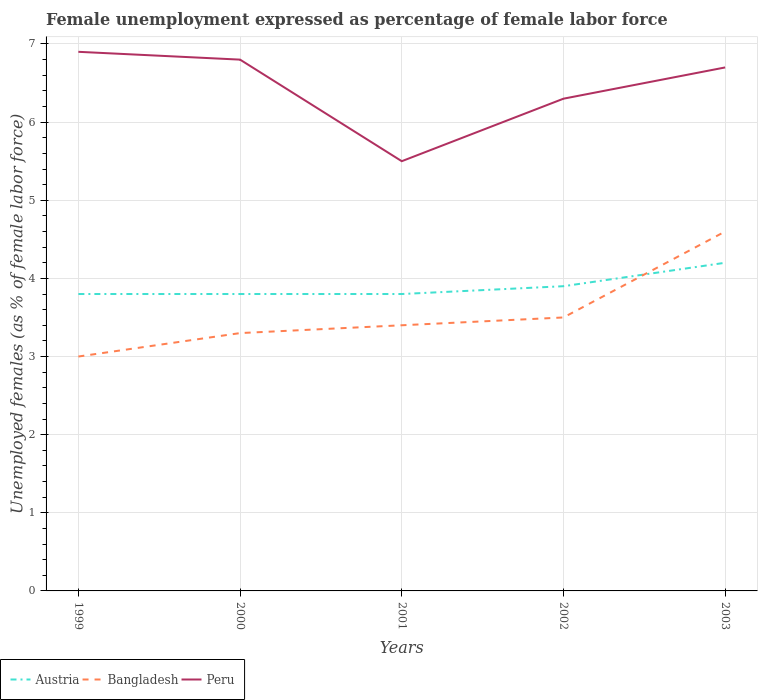Does the line corresponding to Bangladesh intersect with the line corresponding to Austria?
Make the answer very short. Yes. Across all years, what is the maximum unemployment in females in in Bangladesh?
Give a very brief answer. 3. In which year was the unemployment in females in in Austria maximum?
Make the answer very short. 1999. What is the total unemployment in females in in Austria in the graph?
Give a very brief answer. 0. What is the difference between the highest and the second highest unemployment in females in in Austria?
Keep it short and to the point. 0.4. What is the difference between the highest and the lowest unemployment in females in in Austria?
Ensure brevity in your answer.  2. How many lines are there?
Your answer should be very brief. 3. How many years are there in the graph?
Offer a very short reply. 5. Are the values on the major ticks of Y-axis written in scientific E-notation?
Your answer should be very brief. No. Does the graph contain grids?
Provide a succinct answer. Yes. How are the legend labels stacked?
Make the answer very short. Horizontal. What is the title of the graph?
Give a very brief answer. Female unemployment expressed as percentage of female labor force. Does "New Caledonia" appear as one of the legend labels in the graph?
Provide a succinct answer. No. What is the label or title of the X-axis?
Offer a terse response. Years. What is the label or title of the Y-axis?
Provide a succinct answer. Unemployed females (as % of female labor force). What is the Unemployed females (as % of female labor force) in Austria in 1999?
Your answer should be compact. 3.8. What is the Unemployed females (as % of female labor force) of Peru in 1999?
Your response must be concise. 6.9. What is the Unemployed females (as % of female labor force) of Austria in 2000?
Offer a terse response. 3.8. What is the Unemployed females (as % of female labor force) in Bangladesh in 2000?
Your answer should be compact. 3.3. What is the Unemployed females (as % of female labor force) in Peru in 2000?
Offer a terse response. 6.8. What is the Unemployed females (as % of female labor force) in Austria in 2001?
Give a very brief answer. 3.8. What is the Unemployed females (as % of female labor force) in Bangladesh in 2001?
Give a very brief answer. 3.4. What is the Unemployed females (as % of female labor force) of Austria in 2002?
Keep it short and to the point. 3.9. What is the Unemployed females (as % of female labor force) of Peru in 2002?
Ensure brevity in your answer.  6.3. What is the Unemployed females (as % of female labor force) in Austria in 2003?
Make the answer very short. 4.2. What is the Unemployed females (as % of female labor force) in Bangladesh in 2003?
Your answer should be compact. 4.6. What is the Unemployed females (as % of female labor force) in Peru in 2003?
Your answer should be very brief. 6.7. Across all years, what is the maximum Unemployed females (as % of female labor force) in Austria?
Keep it short and to the point. 4.2. Across all years, what is the maximum Unemployed females (as % of female labor force) in Bangladesh?
Your answer should be very brief. 4.6. Across all years, what is the maximum Unemployed females (as % of female labor force) of Peru?
Your answer should be compact. 6.9. Across all years, what is the minimum Unemployed females (as % of female labor force) of Austria?
Your response must be concise. 3.8. Across all years, what is the minimum Unemployed females (as % of female labor force) in Bangladesh?
Your response must be concise. 3. What is the total Unemployed females (as % of female labor force) of Peru in the graph?
Your response must be concise. 32.2. What is the difference between the Unemployed females (as % of female labor force) in Peru in 1999 and that in 2000?
Keep it short and to the point. 0.1. What is the difference between the Unemployed females (as % of female labor force) of Austria in 1999 and that in 2001?
Make the answer very short. 0. What is the difference between the Unemployed females (as % of female labor force) of Bangladesh in 1999 and that in 2001?
Offer a very short reply. -0.4. What is the difference between the Unemployed females (as % of female labor force) of Peru in 1999 and that in 2001?
Offer a terse response. 1.4. What is the difference between the Unemployed females (as % of female labor force) of Austria in 1999 and that in 2002?
Your answer should be compact. -0.1. What is the difference between the Unemployed females (as % of female labor force) in Peru in 1999 and that in 2002?
Your answer should be compact. 0.6. What is the difference between the Unemployed females (as % of female labor force) of Austria in 2000 and that in 2002?
Your response must be concise. -0.1. What is the difference between the Unemployed females (as % of female labor force) in Bangladesh in 2000 and that in 2002?
Offer a very short reply. -0.2. What is the difference between the Unemployed females (as % of female labor force) of Peru in 2000 and that in 2002?
Offer a terse response. 0.5. What is the difference between the Unemployed females (as % of female labor force) of Austria in 2000 and that in 2003?
Offer a very short reply. -0.4. What is the difference between the Unemployed females (as % of female labor force) of Bangladesh in 2001 and that in 2002?
Ensure brevity in your answer.  -0.1. What is the difference between the Unemployed females (as % of female labor force) of Peru in 2001 and that in 2002?
Provide a short and direct response. -0.8. What is the difference between the Unemployed females (as % of female labor force) of Austria in 2001 and that in 2003?
Provide a succinct answer. -0.4. What is the difference between the Unemployed females (as % of female labor force) in Bangladesh in 2001 and that in 2003?
Give a very brief answer. -1.2. What is the difference between the Unemployed females (as % of female labor force) in Peru in 2002 and that in 2003?
Offer a very short reply. -0.4. What is the difference between the Unemployed females (as % of female labor force) of Austria in 1999 and the Unemployed females (as % of female labor force) of Peru in 2000?
Your answer should be compact. -3. What is the difference between the Unemployed females (as % of female labor force) in Bangladesh in 1999 and the Unemployed females (as % of female labor force) in Peru in 2000?
Ensure brevity in your answer.  -3.8. What is the difference between the Unemployed females (as % of female labor force) in Bangladesh in 1999 and the Unemployed females (as % of female labor force) in Peru in 2001?
Your answer should be compact. -2.5. What is the difference between the Unemployed females (as % of female labor force) in Austria in 1999 and the Unemployed females (as % of female labor force) in Peru in 2002?
Provide a short and direct response. -2.5. What is the difference between the Unemployed females (as % of female labor force) of Austria in 1999 and the Unemployed females (as % of female labor force) of Peru in 2003?
Provide a short and direct response. -2.9. What is the difference between the Unemployed females (as % of female labor force) in Bangladesh in 1999 and the Unemployed females (as % of female labor force) in Peru in 2003?
Your answer should be compact. -3.7. What is the difference between the Unemployed females (as % of female labor force) in Austria in 2000 and the Unemployed females (as % of female labor force) in Bangladesh in 2001?
Provide a succinct answer. 0.4. What is the difference between the Unemployed females (as % of female labor force) of Austria in 2000 and the Unemployed females (as % of female labor force) of Peru in 2001?
Your answer should be compact. -1.7. What is the difference between the Unemployed females (as % of female labor force) in Bangladesh in 2000 and the Unemployed females (as % of female labor force) in Peru in 2001?
Give a very brief answer. -2.2. What is the difference between the Unemployed females (as % of female labor force) of Austria in 2000 and the Unemployed females (as % of female labor force) of Bangladesh in 2002?
Give a very brief answer. 0.3. What is the difference between the Unemployed females (as % of female labor force) in Austria in 2000 and the Unemployed females (as % of female labor force) in Peru in 2002?
Provide a short and direct response. -2.5. What is the difference between the Unemployed females (as % of female labor force) in Bangladesh in 2000 and the Unemployed females (as % of female labor force) in Peru in 2002?
Keep it short and to the point. -3. What is the difference between the Unemployed females (as % of female labor force) of Austria in 2001 and the Unemployed females (as % of female labor force) of Peru in 2002?
Keep it short and to the point. -2.5. What is the difference between the Unemployed females (as % of female labor force) in Bangladesh in 2001 and the Unemployed females (as % of female labor force) in Peru in 2002?
Your answer should be compact. -2.9. What is the difference between the Unemployed females (as % of female labor force) in Austria in 2001 and the Unemployed females (as % of female labor force) in Bangladesh in 2003?
Your answer should be compact. -0.8. What is the difference between the Unemployed females (as % of female labor force) of Austria in 2001 and the Unemployed females (as % of female labor force) of Peru in 2003?
Make the answer very short. -2.9. What is the average Unemployed females (as % of female labor force) in Bangladesh per year?
Provide a short and direct response. 3.56. What is the average Unemployed females (as % of female labor force) of Peru per year?
Offer a terse response. 6.44. In the year 2000, what is the difference between the Unemployed females (as % of female labor force) in Austria and Unemployed females (as % of female labor force) in Peru?
Ensure brevity in your answer.  -3. In the year 2000, what is the difference between the Unemployed females (as % of female labor force) in Bangladesh and Unemployed females (as % of female labor force) in Peru?
Your answer should be compact. -3.5. In the year 2001, what is the difference between the Unemployed females (as % of female labor force) of Austria and Unemployed females (as % of female labor force) of Peru?
Ensure brevity in your answer.  -1.7. In the year 2002, what is the difference between the Unemployed females (as % of female labor force) in Austria and Unemployed females (as % of female labor force) in Bangladesh?
Your answer should be very brief. 0.4. In the year 2003, what is the difference between the Unemployed females (as % of female labor force) in Austria and Unemployed females (as % of female labor force) in Bangladesh?
Make the answer very short. -0.4. What is the ratio of the Unemployed females (as % of female labor force) in Austria in 1999 to that in 2000?
Your answer should be very brief. 1. What is the ratio of the Unemployed females (as % of female labor force) of Bangladesh in 1999 to that in 2000?
Make the answer very short. 0.91. What is the ratio of the Unemployed females (as % of female labor force) in Peru in 1999 to that in 2000?
Provide a succinct answer. 1.01. What is the ratio of the Unemployed females (as % of female labor force) of Austria in 1999 to that in 2001?
Your response must be concise. 1. What is the ratio of the Unemployed females (as % of female labor force) of Bangladesh in 1999 to that in 2001?
Your response must be concise. 0.88. What is the ratio of the Unemployed females (as % of female labor force) in Peru in 1999 to that in 2001?
Make the answer very short. 1.25. What is the ratio of the Unemployed females (as % of female labor force) in Austria in 1999 to that in 2002?
Provide a short and direct response. 0.97. What is the ratio of the Unemployed females (as % of female labor force) of Bangladesh in 1999 to that in 2002?
Give a very brief answer. 0.86. What is the ratio of the Unemployed females (as % of female labor force) of Peru in 1999 to that in 2002?
Your response must be concise. 1.1. What is the ratio of the Unemployed females (as % of female labor force) of Austria in 1999 to that in 2003?
Provide a short and direct response. 0.9. What is the ratio of the Unemployed females (as % of female labor force) of Bangladesh in 1999 to that in 2003?
Make the answer very short. 0.65. What is the ratio of the Unemployed females (as % of female labor force) of Peru in 1999 to that in 2003?
Ensure brevity in your answer.  1.03. What is the ratio of the Unemployed females (as % of female labor force) of Austria in 2000 to that in 2001?
Ensure brevity in your answer.  1. What is the ratio of the Unemployed females (as % of female labor force) in Bangladesh in 2000 to that in 2001?
Your answer should be very brief. 0.97. What is the ratio of the Unemployed females (as % of female labor force) in Peru in 2000 to that in 2001?
Your answer should be compact. 1.24. What is the ratio of the Unemployed females (as % of female labor force) of Austria in 2000 to that in 2002?
Keep it short and to the point. 0.97. What is the ratio of the Unemployed females (as % of female labor force) of Bangladesh in 2000 to that in 2002?
Your answer should be very brief. 0.94. What is the ratio of the Unemployed females (as % of female labor force) of Peru in 2000 to that in 2002?
Keep it short and to the point. 1.08. What is the ratio of the Unemployed females (as % of female labor force) of Austria in 2000 to that in 2003?
Offer a terse response. 0.9. What is the ratio of the Unemployed females (as % of female labor force) of Bangladesh in 2000 to that in 2003?
Offer a very short reply. 0.72. What is the ratio of the Unemployed females (as % of female labor force) in Peru in 2000 to that in 2003?
Your response must be concise. 1.01. What is the ratio of the Unemployed females (as % of female labor force) in Austria in 2001 to that in 2002?
Keep it short and to the point. 0.97. What is the ratio of the Unemployed females (as % of female labor force) in Bangladesh in 2001 to that in 2002?
Keep it short and to the point. 0.97. What is the ratio of the Unemployed females (as % of female labor force) of Peru in 2001 to that in 2002?
Provide a short and direct response. 0.87. What is the ratio of the Unemployed females (as % of female labor force) of Austria in 2001 to that in 2003?
Offer a very short reply. 0.9. What is the ratio of the Unemployed females (as % of female labor force) of Bangladesh in 2001 to that in 2003?
Provide a succinct answer. 0.74. What is the ratio of the Unemployed females (as % of female labor force) of Peru in 2001 to that in 2003?
Your answer should be compact. 0.82. What is the ratio of the Unemployed females (as % of female labor force) in Austria in 2002 to that in 2003?
Offer a terse response. 0.93. What is the ratio of the Unemployed females (as % of female labor force) in Bangladesh in 2002 to that in 2003?
Provide a succinct answer. 0.76. What is the ratio of the Unemployed females (as % of female labor force) in Peru in 2002 to that in 2003?
Your answer should be compact. 0.94. What is the difference between the highest and the second highest Unemployed females (as % of female labor force) of Bangladesh?
Your response must be concise. 1.1. What is the difference between the highest and the second highest Unemployed females (as % of female labor force) in Peru?
Provide a short and direct response. 0.1. 